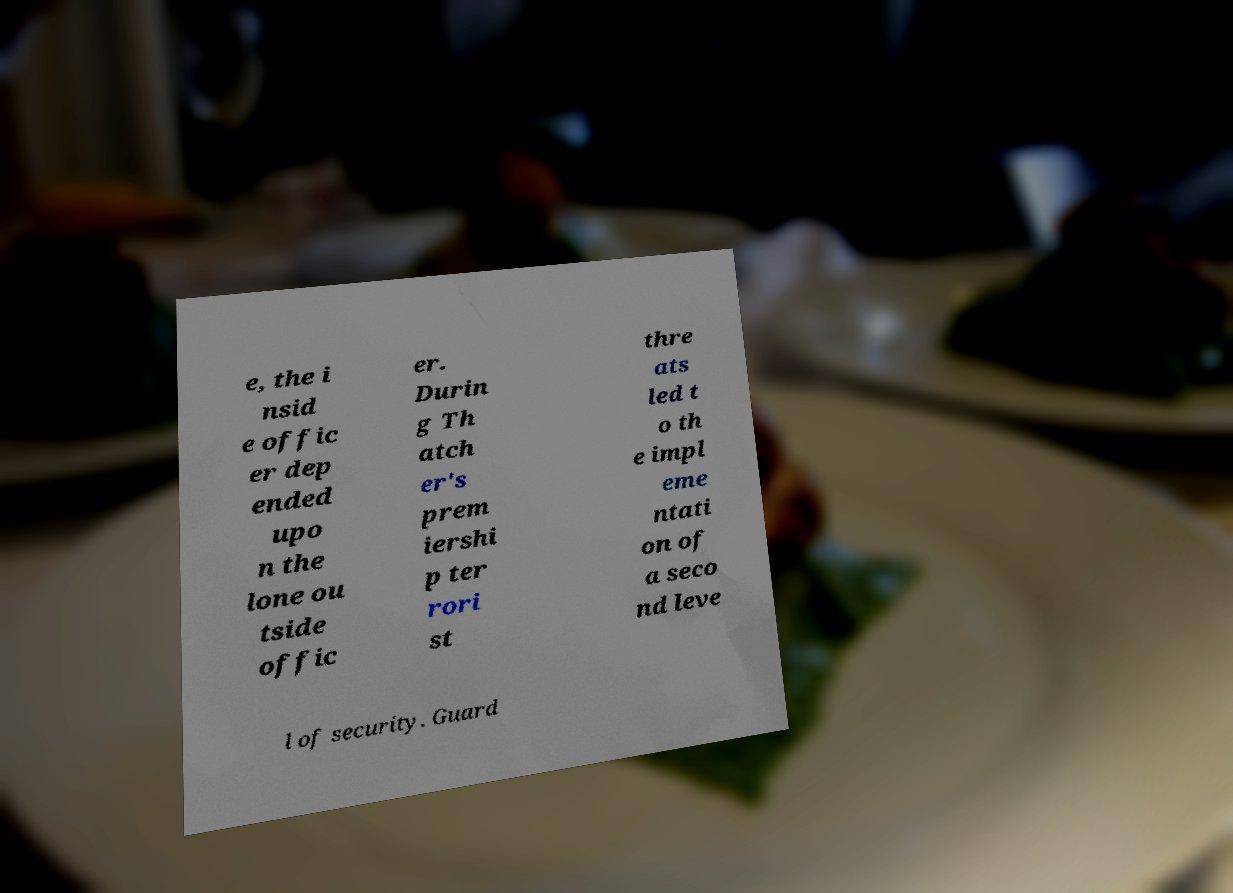Can you read and provide the text displayed in the image?This photo seems to have some interesting text. Can you extract and type it out for me? e, the i nsid e offic er dep ended upo n the lone ou tside offic er. Durin g Th atch er's prem iershi p ter rori st thre ats led t o th e impl eme ntati on of a seco nd leve l of security. Guard 